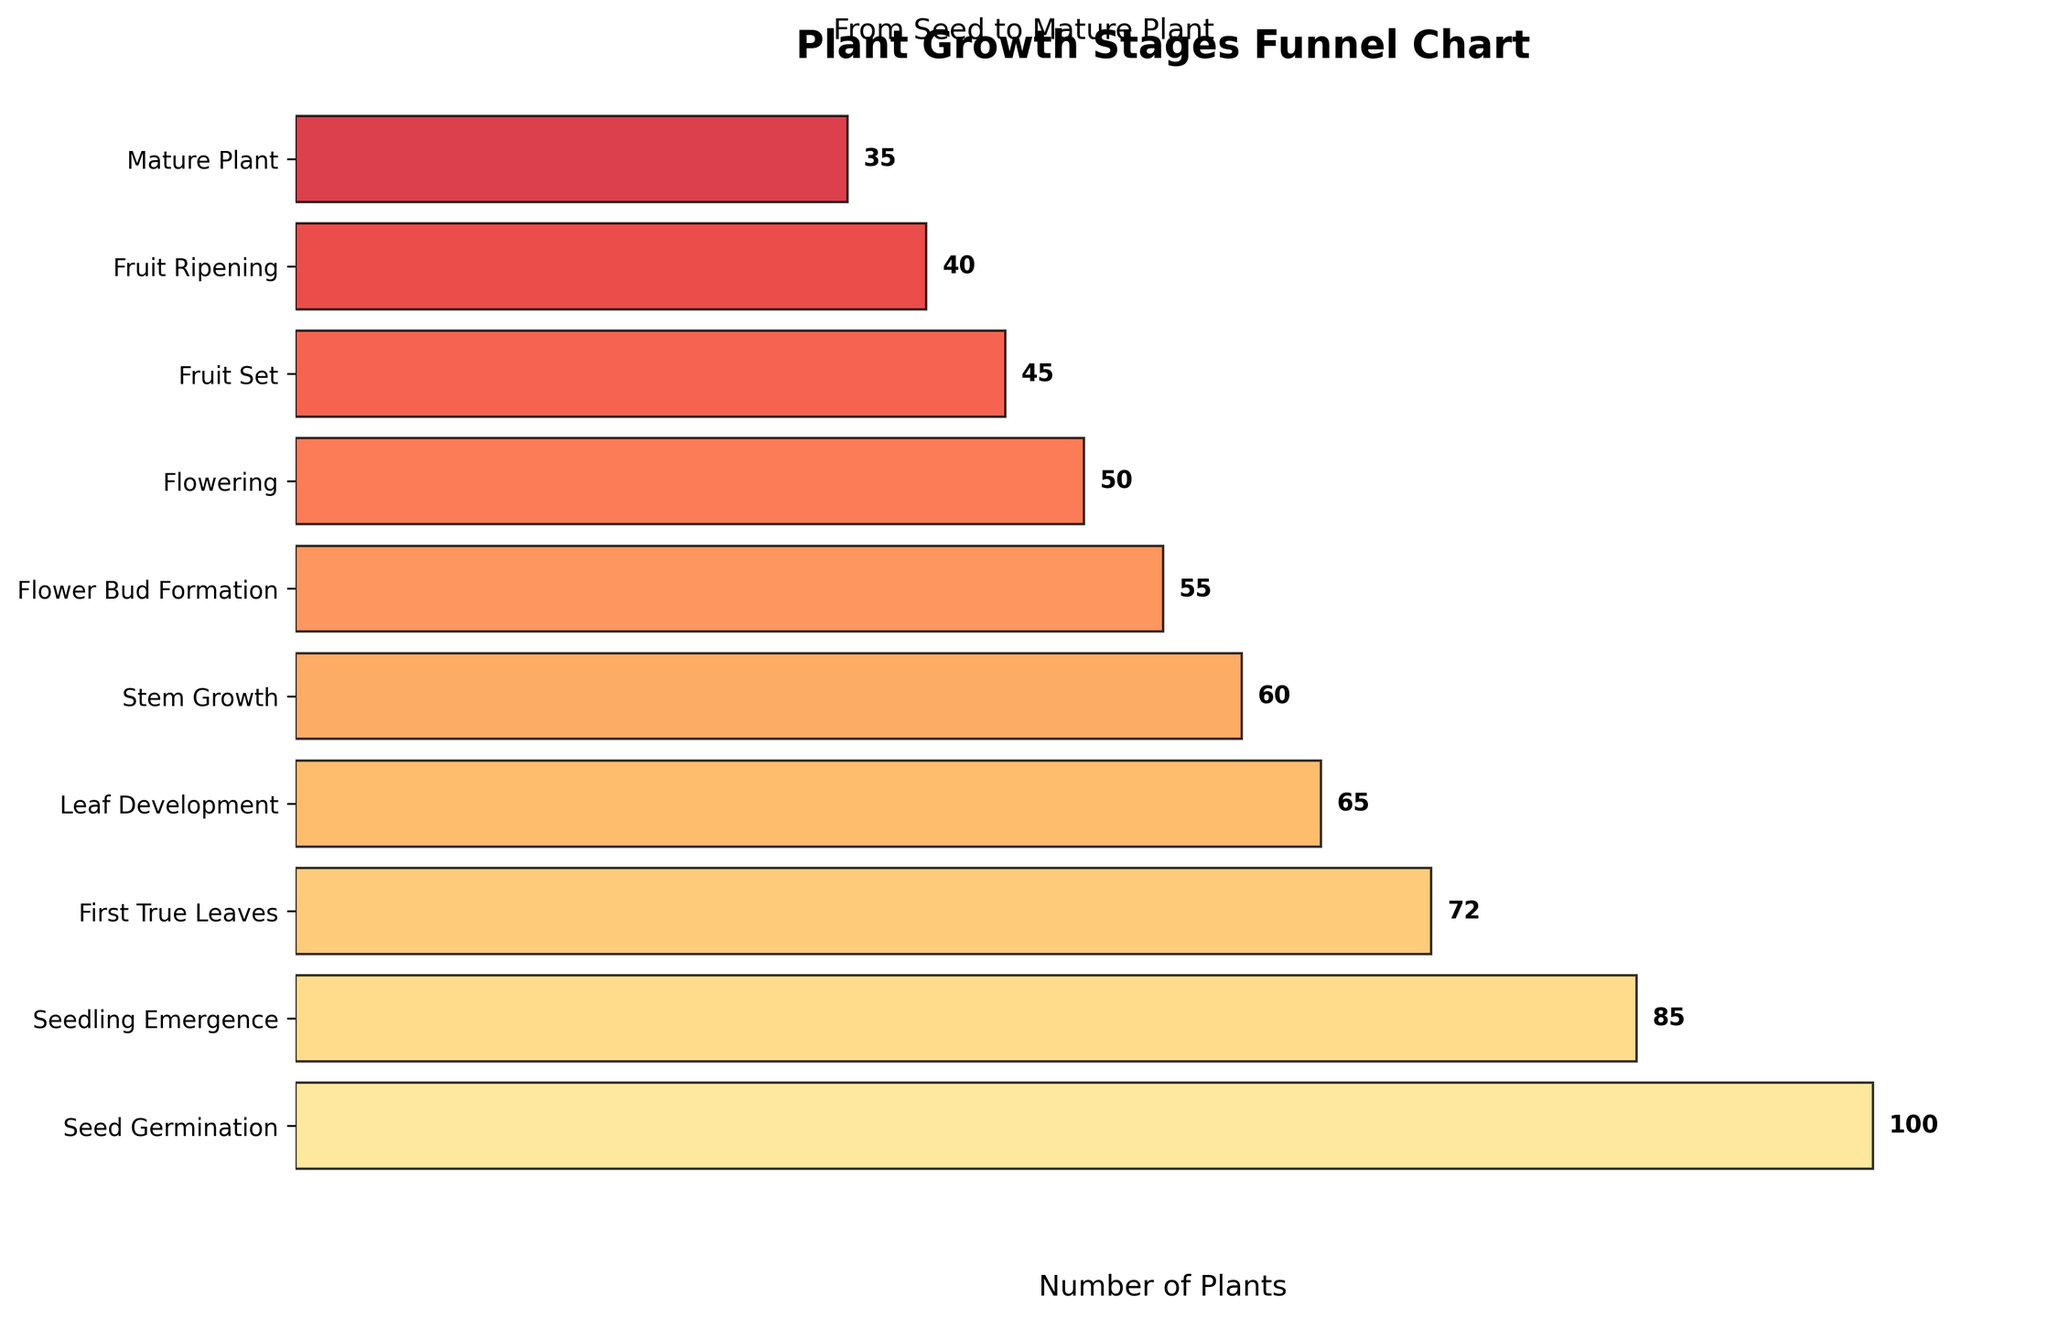What is the title of the chart? The title is located at the top of the chart. It reads: "Plant Growth Stages Funnel Chart".
Answer: Plant Growth Stages Funnel Chart Which stage has the highest number of plants? The stage with the highest number of plants is displayed at the top of the funnel chart.
Answer: Seed Germination How many stages are there in the plant growth process shown in the chart? By counting the number of labeled stages on the left side of the funnel chart, one can determine the total number of stages.
Answer: 10 At which stage do the number of plants drop below 50? Moving from the top of the funnel to the bottom, the number of plants first drops below 50 at the "Flower Bud Formation" stage.
Answer: Flower Bud Formation What is the difference in the number of plants between the "Stem Growth" and "Flowering" stages? The number of plants at "Stem Growth" is 60 and at "Flowering" it's 50. The difference is calculated as 60 - 50.
Answer: 10 Which color seems the most prominent as the stages progress? Observing the colors from the top to the bottom of the funnel, the shades gradually become more reddish. The most prominent color appears orange to red.
Answer: Orange to Red How many plants reach the "Mature Plant" stage? The number of plants at the "Mature Plant" stage is displayed next to its label on the right of the funnel.
Answer: 35 What is the average number of plants from "Fruit Set" to "Mature Plant"? The values for these stages are 45, 40, and 35 respectively. The average is calculated by summing these numbers and dividing by the count of stages: (45 + 40 + 35) / 3.
Answer: 40 Which two consecutive stages have the smallest difference in the number of plants? By comparing the differences between each pair of consecutive stages, the smallest difference occurs between "Flowering" and "Fruit Set" stages.
Answer: Flowering and Fruit Set What general trend is observed in the number of plants as they progress through the stages? Observing the funnel chart from top to bottom, the number of plants generally decreases at each subsequent stage.
Answer: Decreasing trend 